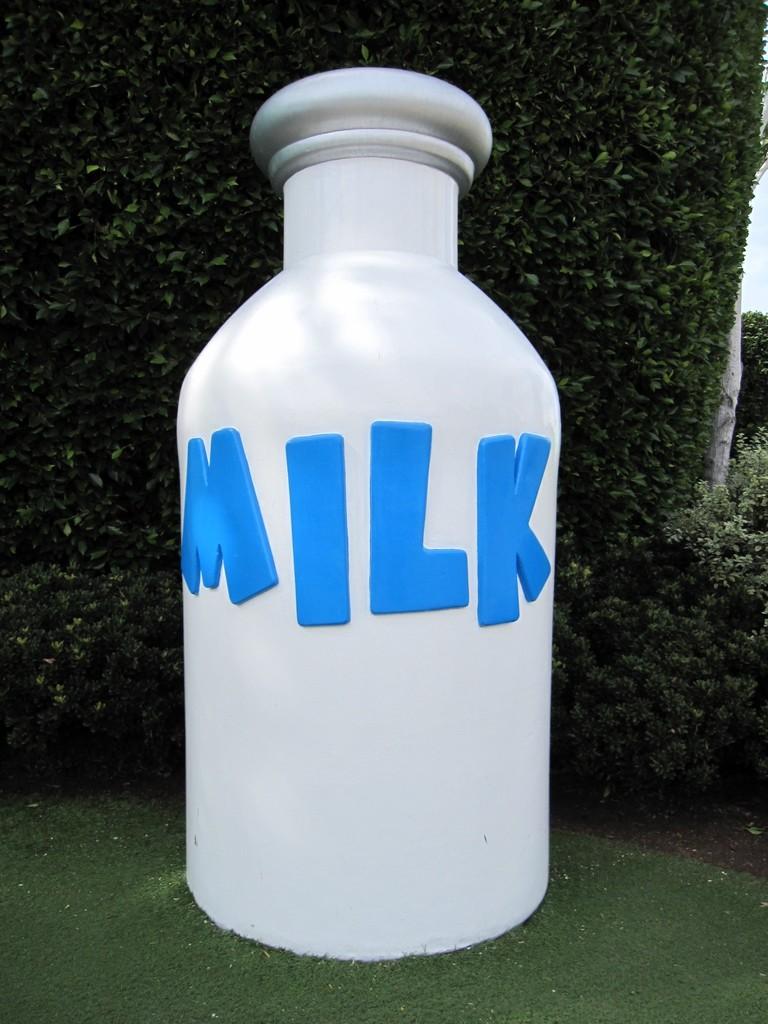What is written on this bottle?
Your answer should be very brief. Milk. 